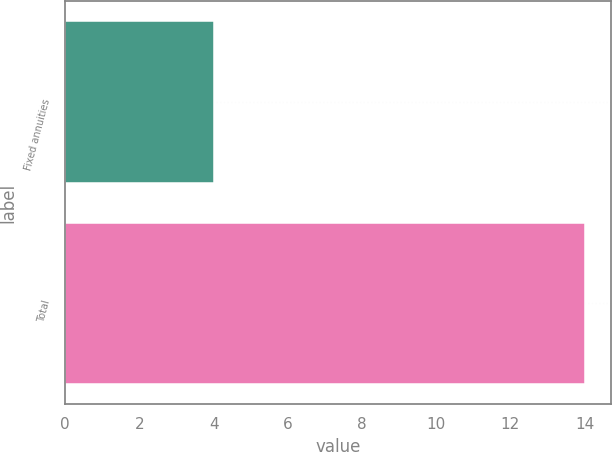Convert chart to OTSL. <chart><loc_0><loc_0><loc_500><loc_500><bar_chart><fcel>Fixed annuities<fcel>Total<nl><fcel>4<fcel>14<nl></chart> 